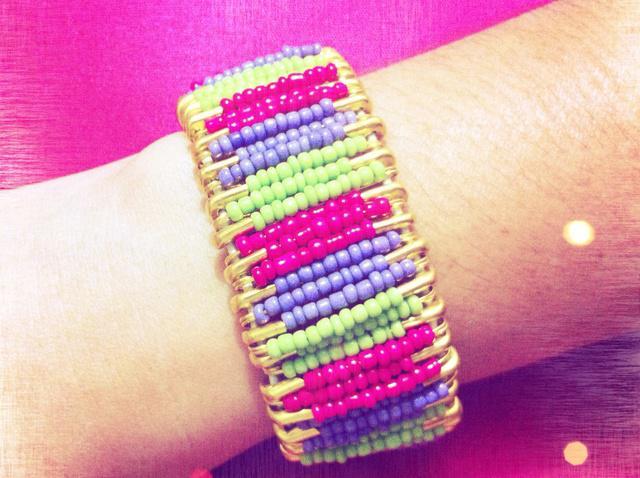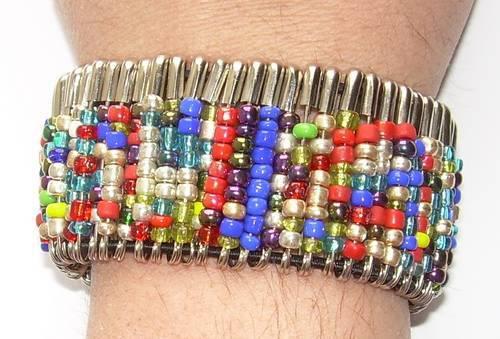The first image is the image on the left, the second image is the image on the right. Given the left and right images, does the statement "In the right image, the bracelet is shown on a wrist." hold true? Answer yes or no. Yes. The first image is the image on the left, the second image is the image on the right. Evaluate the accuracy of this statement regarding the images: "there is an arm in the image on the right.". Is it true? Answer yes or no. Yes. 